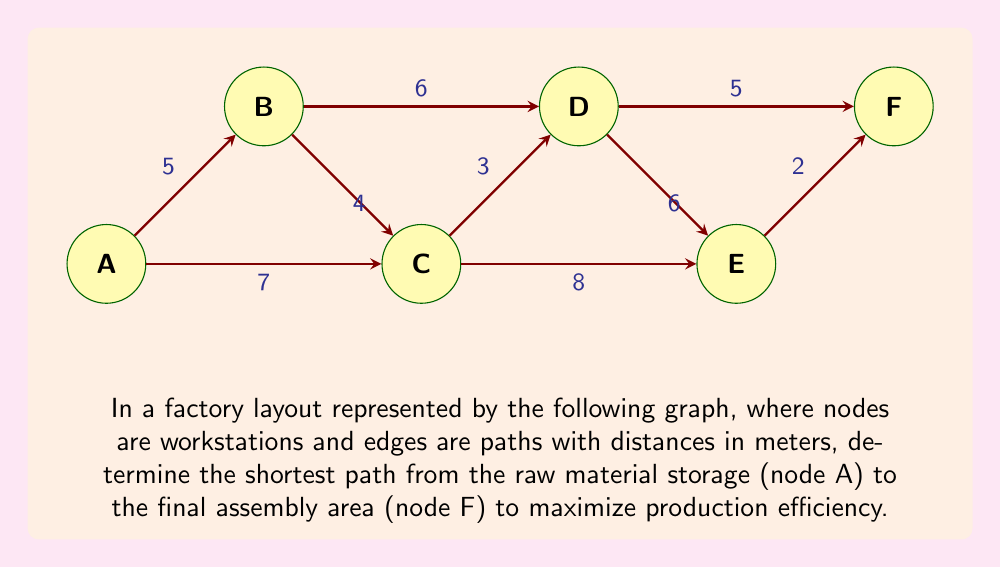Can you answer this question? To find the shortest path from A to F, we'll use Dijkstra's algorithm:

1) Initialize:
   - Distance to A = 0
   - Distance to all other nodes = $\infty$
   - Set of unvisited nodes = {A, B, C, D, E, F}

2) From A:
   - Update: d(B) = 5, d(C) = 7
   - Choose B (shorter distance)

3) From B:
   - Update: d(C) = min(7, 5+4) = 7, d(D) = 5+6 = 11
   - Choose C

4) From C:
   - Update: d(D) = min(11, 7+3) = 10, d(E) = 7+8 = 15
   - Choose D

5) From D:
   - Update: d(E) = min(15, 10+6) = 15, d(F) = 10+5 = 15
   - Choose F (tie with E, but F is our target)

The shortest path is A → B → C → D → F with a total distance of 15 meters.

To verify:
A → B: 5m
B → C: 4m
C → D: 3m
D → F: 5m
Total: 5 + 4 + 3 + 5 = 17m

This path ensures the fastest material flow from raw storage to final assembly, maximizing production efficiency.
Answer: A → B → C → D → F, 17m 